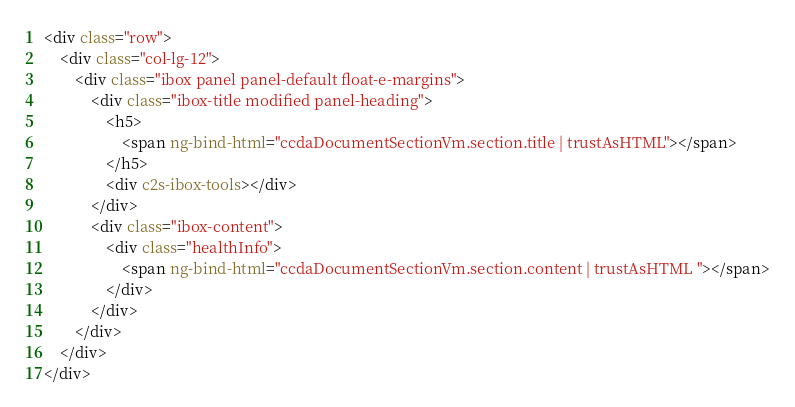<code> <loc_0><loc_0><loc_500><loc_500><_HTML_><div class="row">
    <div class="col-lg-12">
        <div class="ibox panel panel-default float-e-margins">
            <div class="ibox-title modified panel-heading">
                <h5>
                    <span ng-bind-html="ccdaDocumentSectionVm.section.title | trustAsHTML"></span>
                </h5>
                <div c2s-ibox-tools></div>
            </div>
            <div class="ibox-content">
                <div class="healthInfo">
                    <span ng-bind-html="ccdaDocumentSectionVm.section.content | trustAsHTML "></span>
                </div>
            </div>
        </div>
    </div>
</div></code> 